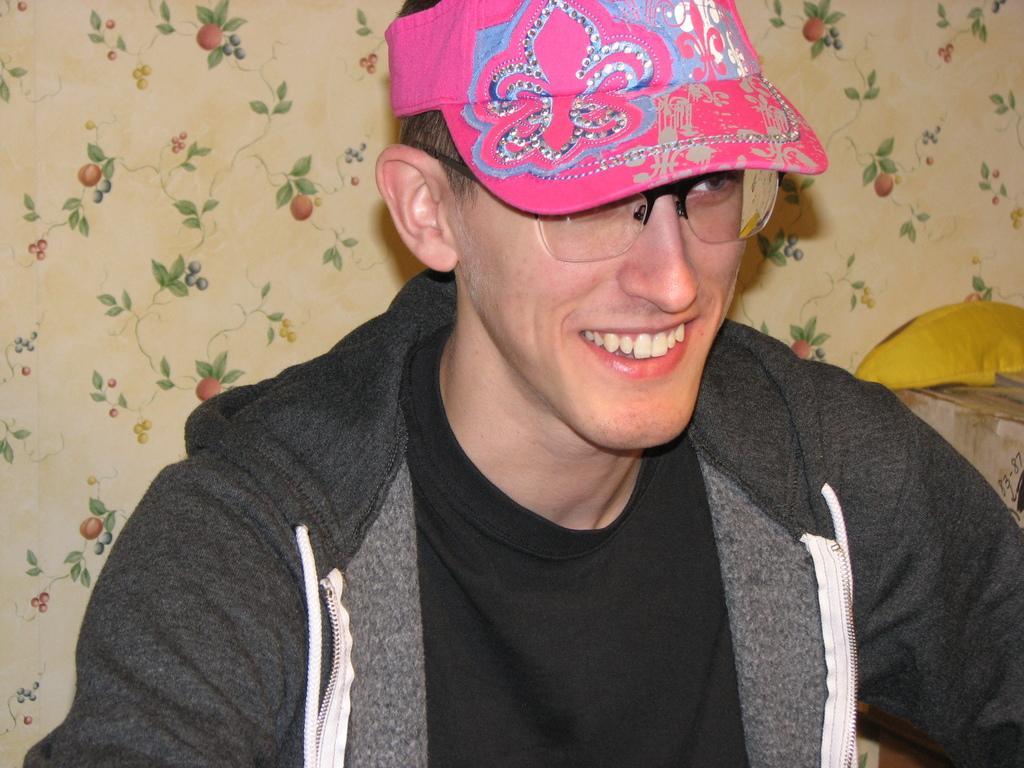Can you describe this image briefly? Here I can see a man wearing a jacket, black color t-shirt, pink color cap on the head, smiling and looking at the right side. At the back of this man I can see a curtain. 